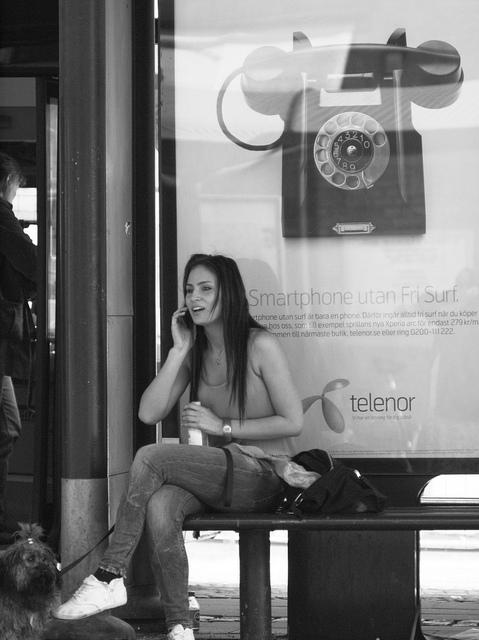Will the dog run away?
Quick response, please. No. Can the woman use the phone above her head to make a call?
Quick response, please. No. How is the women sitting?
Be succinct. Legs crossed. 